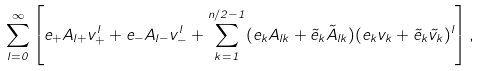Convert formula to latex. <formula><loc_0><loc_0><loc_500><loc_500>\sum _ { l = 0 } ^ { \infty } \left [ e _ { + } A _ { l + } v _ { + } ^ { l } + e _ { - } A _ { l - } v _ { - } ^ { l } + \sum _ { k = 1 } ^ { n / 2 - 1 } ( e _ { k } A _ { l k } + \tilde { e } _ { k } \tilde { A } _ { l k } ) ( e _ { k } v _ { k } + \tilde { e } _ { k } \tilde { v } _ { k } ) ^ { l } \right ] ,</formula> 